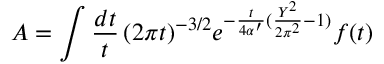<formula> <loc_0><loc_0><loc_500><loc_500>A = \int \frac { d t } { t } \, ( 2 \pi t ) ^ { - 3 / 2 } e ^ { - { \frac { t } { 4 \alpha ^ { \prime } } } ( { \frac { Y ^ { 2 } } { 2 \pi ^ { 2 } } } - 1 ) } f ( t )</formula> 